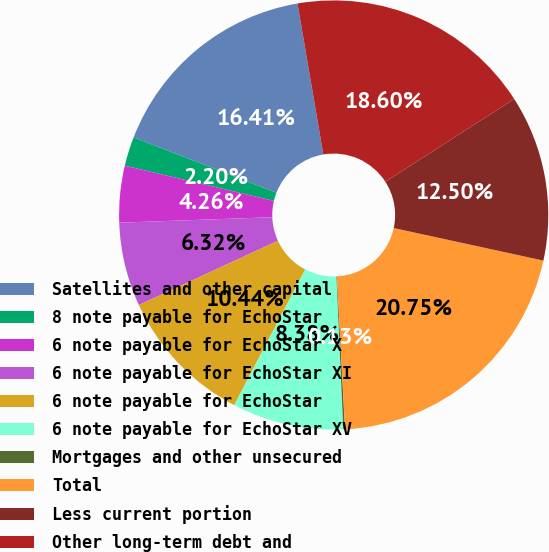<chart> <loc_0><loc_0><loc_500><loc_500><pie_chart><fcel>Satellites and other capital<fcel>8 note payable for EchoStar<fcel>6 note payable for EchoStar X<fcel>6 note payable for EchoStar XI<fcel>6 note payable for EchoStar<fcel>6 note payable for EchoStar XV<fcel>Mortgages and other unsecured<fcel>Total<fcel>Less current portion<fcel>Other long-term debt and<nl><fcel>16.41%<fcel>2.2%<fcel>4.26%<fcel>6.32%<fcel>10.44%<fcel>8.38%<fcel>0.13%<fcel>20.75%<fcel>12.5%<fcel>18.6%<nl></chart> 